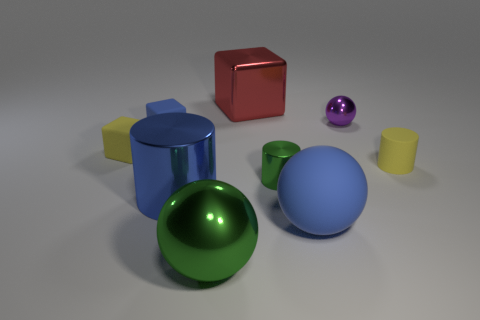Does the blue shiny object have the same shape as the small green metallic object? yes 